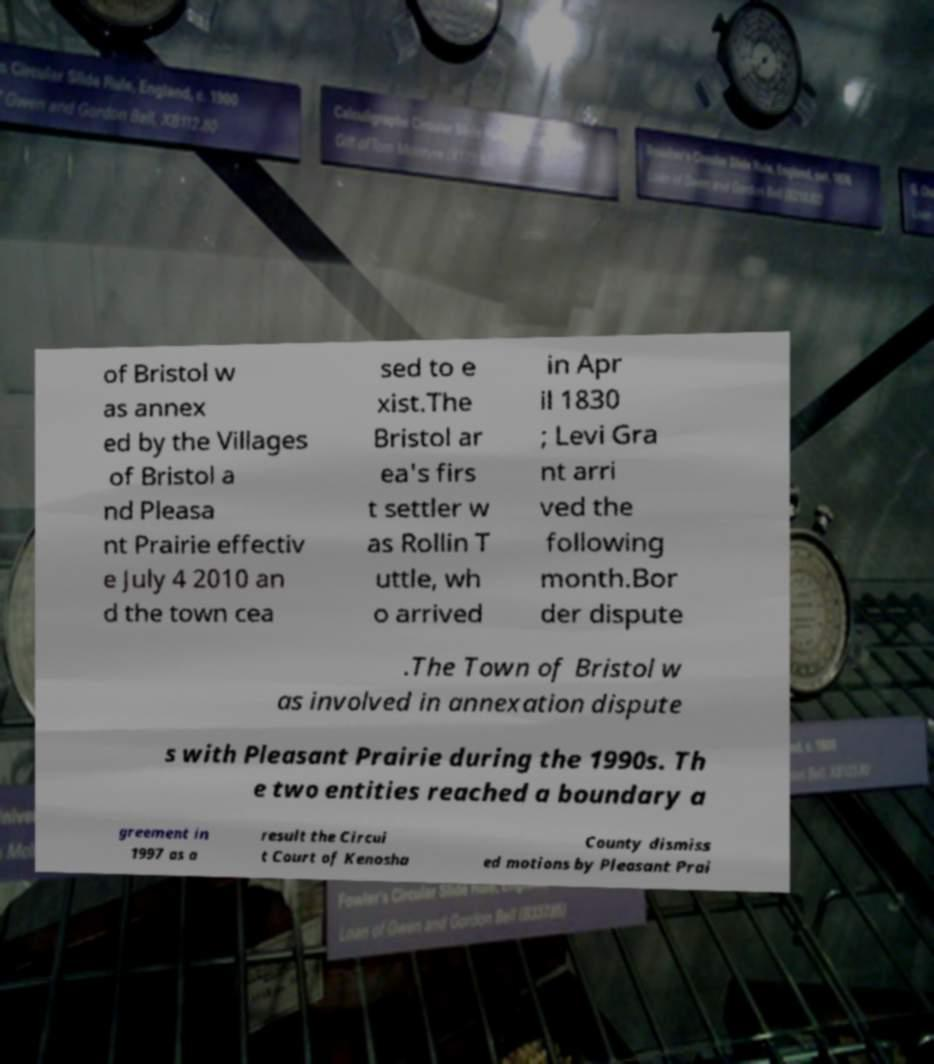What messages or text are displayed in this image? I need them in a readable, typed format. of Bristol w as annex ed by the Villages of Bristol a nd Pleasa nt Prairie effectiv e July 4 2010 an d the town cea sed to e xist.The Bristol ar ea's firs t settler w as Rollin T uttle, wh o arrived in Apr il 1830 ; Levi Gra nt arri ved the following month.Bor der dispute .The Town of Bristol w as involved in annexation dispute s with Pleasant Prairie during the 1990s. Th e two entities reached a boundary a greement in 1997 as a result the Circui t Court of Kenosha County dismiss ed motions by Pleasant Prai 